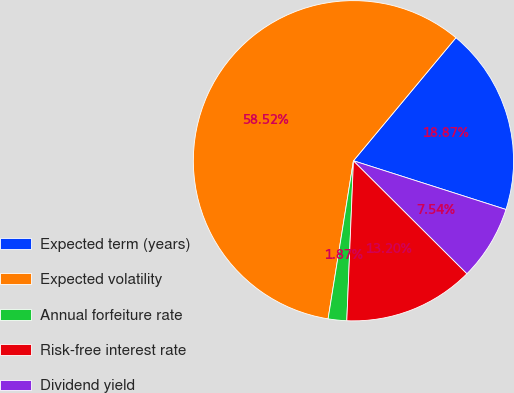Convert chart. <chart><loc_0><loc_0><loc_500><loc_500><pie_chart><fcel>Expected term (years)<fcel>Expected volatility<fcel>Annual forfeiture rate<fcel>Risk-free interest rate<fcel>Dividend yield<nl><fcel>18.87%<fcel>58.52%<fcel>1.87%<fcel>13.2%<fcel>7.54%<nl></chart> 